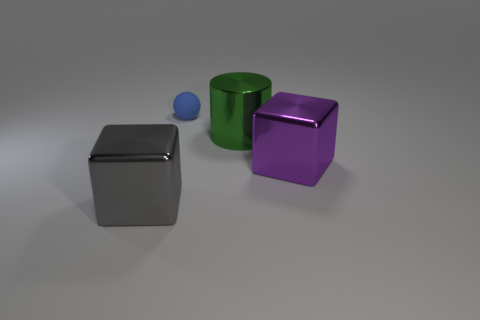Add 3 blue objects. How many objects exist? 7 Subtract all cylinders. How many objects are left? 3 Add 3 green shiny cylinders. How many green shiny cylinders are left? 4 Add 3 big rubber blocks. How many big rubber blocks exist? 3 Subtract 0 brown cylinders. How many objects are left? 4 Subtract all tiny brown objects. Subtract all large purple metal blocks. How many objects are left? 3 